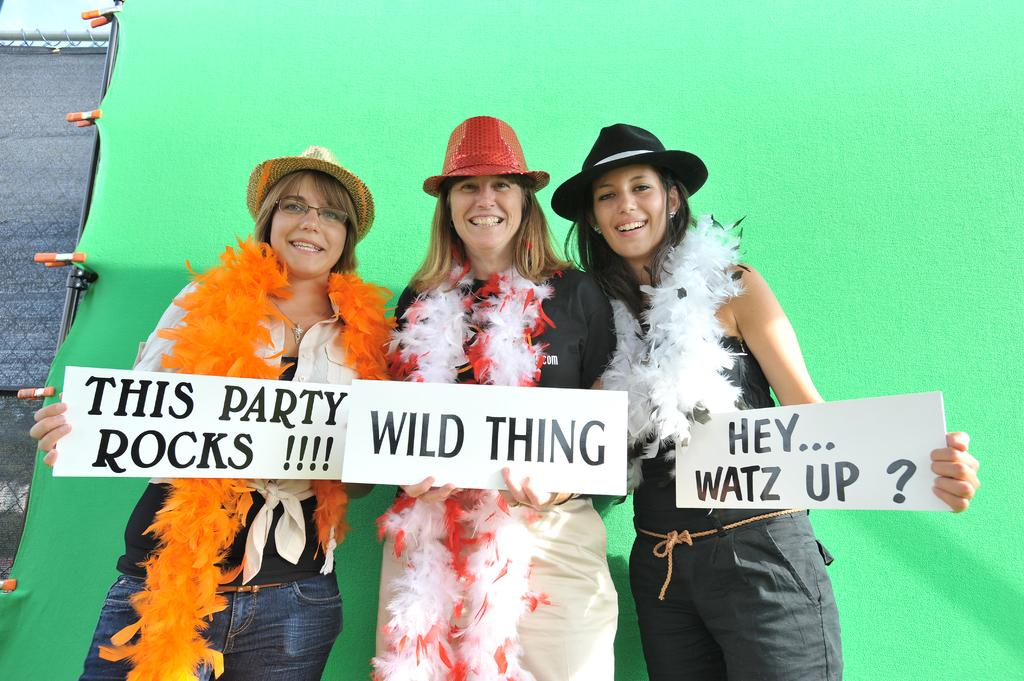How many ladies are present in the image? There are three ladies in the image. What are the ladies wearing on their heads? The ladies are wearing hats. What type of scarves are the ladies wearing? The ladies are wearing scarves made of feathers. What are the ladies holding in the image? The ladies are holding placards. What can be seen in the background of the image? There is a green wall in the background. What is attached to the side of the wall? There are clips on the side of the wall. What type of apparel is the wrench wearing in the image? There is no wrench present in the image, so it cannot be wearing any apparel. Can you describe the leaf's role in the protest depicted in the image? There is no leaf present in the image, so it cannot have a role in the protest. 